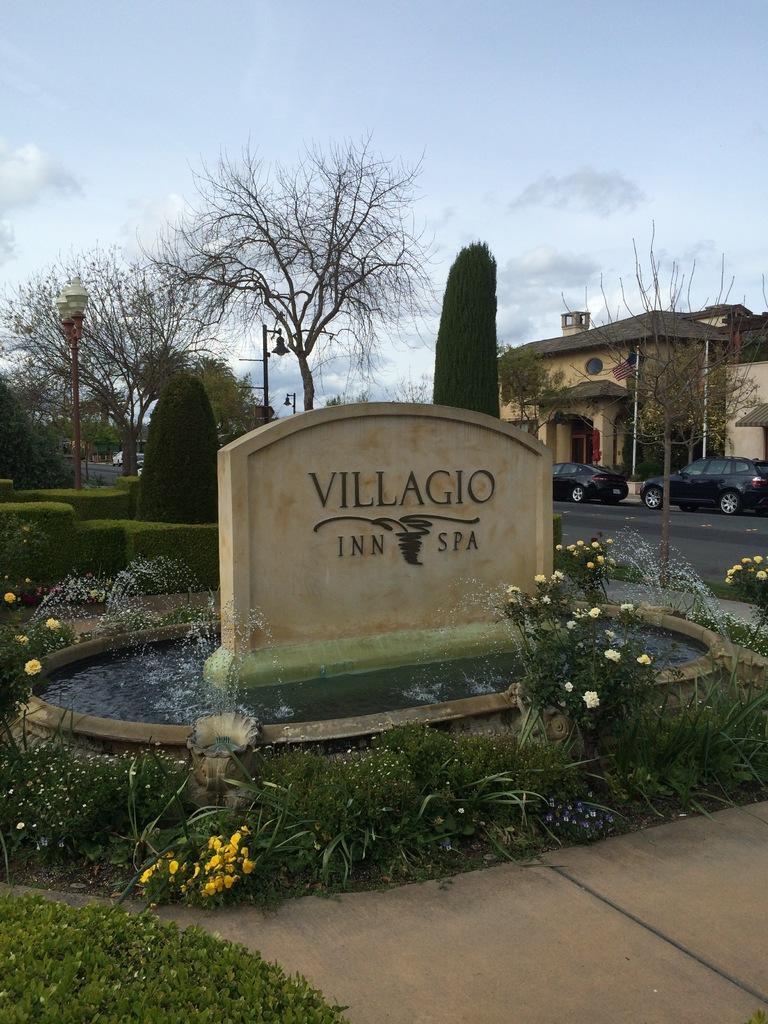Describe this image in one or two sentences. In this image we can see a fountain. There is a pavement and plants at the bottom of the image. In the background of the image, we can see building, cars on the road, poles, trees and plants. There is the sky with some clouds at the top. 